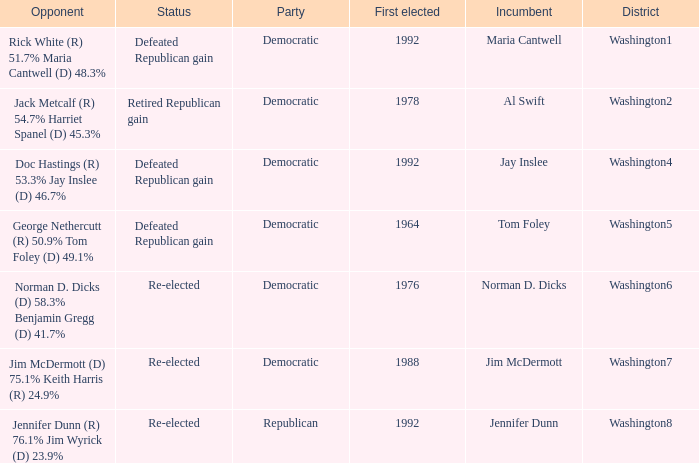What was the result of the election of doc hastings (r) 53.3% jay inslee (d) 46.7% Defeated Republican gain. 